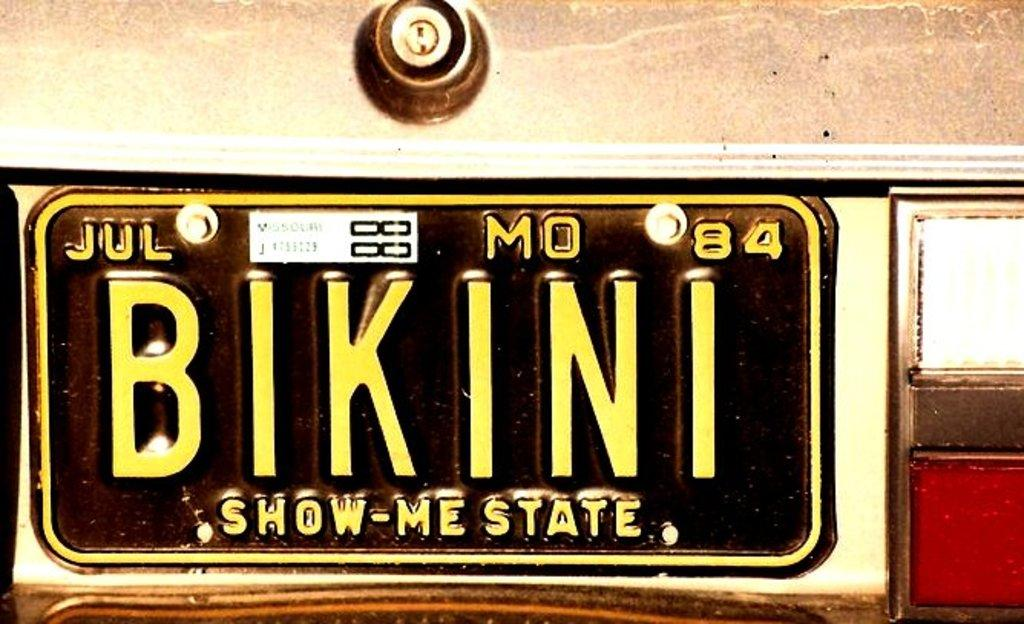<image>
Describe the image concisely. Black license plate which says BIKINI on it. 